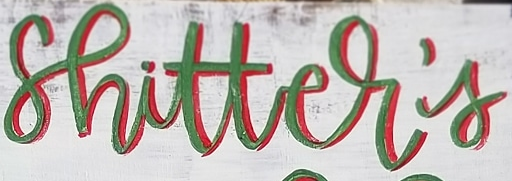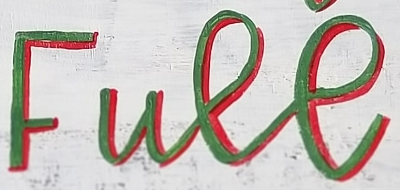What words are shown in these images in order, separated by a semicolon? shitter's; Full 